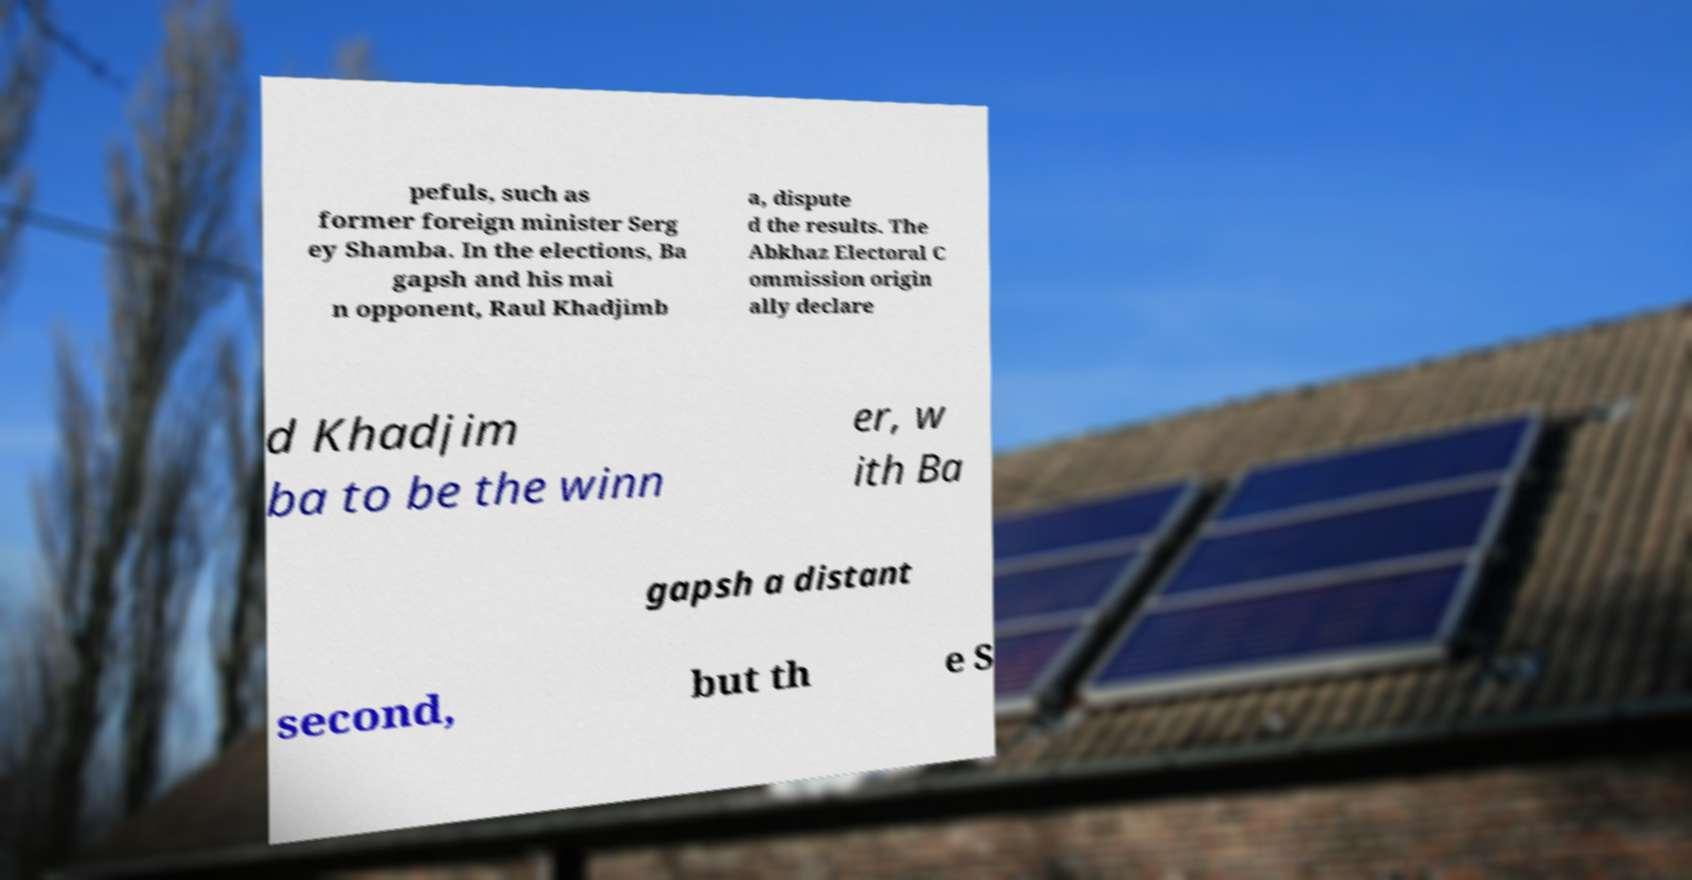I need the written content from this picture converted into text. Can you do that? pefuls, such as former foreign minister Serg ey Shamba. In the elections, Ba gapsh and his mai n opponent, Raul Khadjimb a, dispute d the results. The Abkhaz Electoral C ommission origin ally declare d Khadjim ba to be the winn er, w ith Ba gapsh a distant second, but th e S 